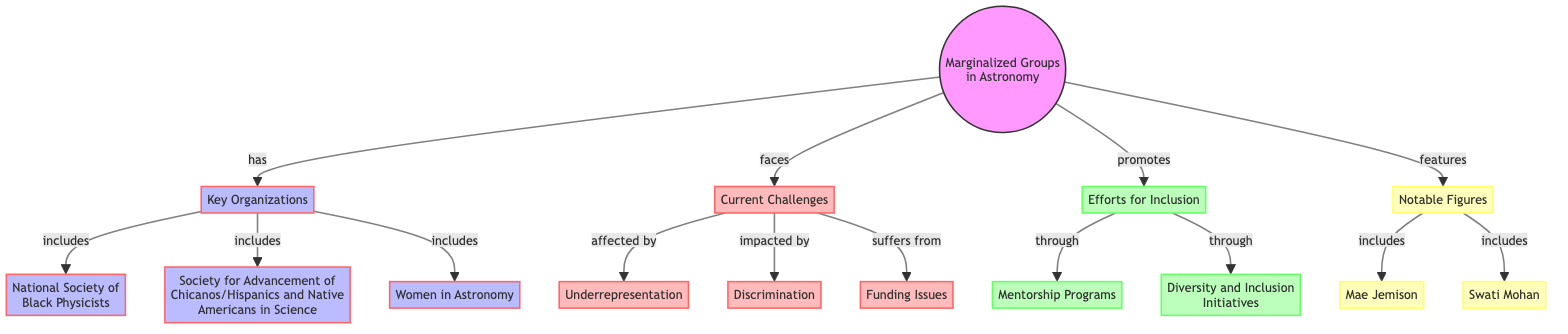What organizations are included under Key Organizations? The diagram identifies three organizations under Key Organizations: the National Society of Black Physicists, Society for Advancement of Chicanos/Hispanics and Native Americans in Science, and Women in Astronomy.
Answer: National Society of Black Physicists, Society for Advancement of Chicanos/Hispanics and Native Americans in Science, Women in Astronomy What challenges do marginalized groups in astronomy face? The diagram lists three challenges that marginalized groups face: Underrepresentation, Discrimination, and Funding Issues.
Answer: Underrepresentation, Discrimination, Funding Issues How many notable figures are mentioned in the diagram? The diagram includes two notable figures associated with marginalized groups in astronomy: Mae Jemison and Swati Mohan.
Answer: 2 What initiative is a part of efforts for inclusion? According to the diagram, one of the initiatives under efforts for inclusion is Diversity and Inclusion Initiatives, which aims to promote representation.
Answer: Diversity and Inclusion Initiatives Which specific organization is dedicated to the advocacy of women in astronomy? Women in Astronomy is specifically mentioned as an organization dedicated to the advocacy of women within the field of astronomy.
Answer: Women in Astronomy How are the current challenges related to marginalized groups described in the diagram? The diagram illustrates that current challenges include underrepresentation, discrimination, and funding issues, which are all interconnected as they impact marginalized groups in astronomy.
Answer: Underrepresentation, Discrimination, Funding Issues What does the diagram suggest promoting through mentorship programs? The diagram indicates that mentorship programs are part of efforts for inclusion, suggesting a focus on improving representation of marginalized groups through guidance and support.
Answer: Improving representation Which notable figure was the first African-American woman in space? Mae Jemison is recognized in the diagram as the first African-American woman in space, highlighting her significance within marginalized groups in astronomy.
Answer: Mae Jemison What connects key organizations and current challenges in the diagram? The diagram shows that marginalized groups in astronomy face current challenges, which are represented by three nodes: underrepresentation, discrimination, and funding issues, all linked to key organizations that serve these groups.
Answer: Key Organizations and Current Challenges connection 